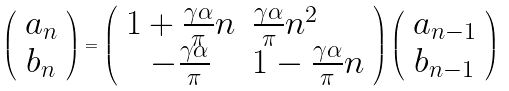<formula> <loc_0><loc_0><loc_500><loc_500>\left ( \begin{array} { c } a _ { n } \\ b _ { n } \end{array} \right ) = \left ( \begin{array} { c l } 1 + \frac { \gamma \alpha } { \pi } n & \frac { \gamma \alpha } { \pi } n ^ { 2 } \\ - \frac { \gamma \alpha } { \pi } & 1 - \frac { \gamma \alpha } { \pi } n \end{array} \right ) \left ( \begin{array} { c } a _ { n - 1 } \\ b _ { n - 1 } \end{array} \right )</formula> 